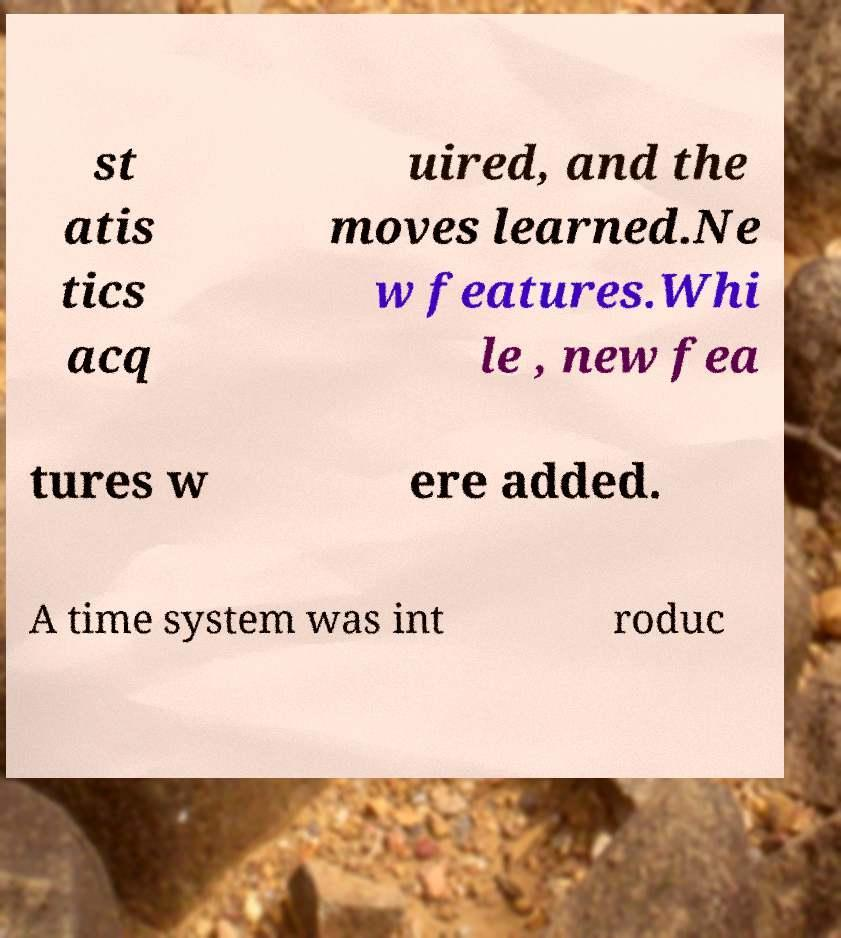Could you assist in decoding the text presented in this image and type it out clearly? st atis tics acq uired, and the moves learned.Ne w features.Whi le , new fea tures w ere added. A time system was int roduc 